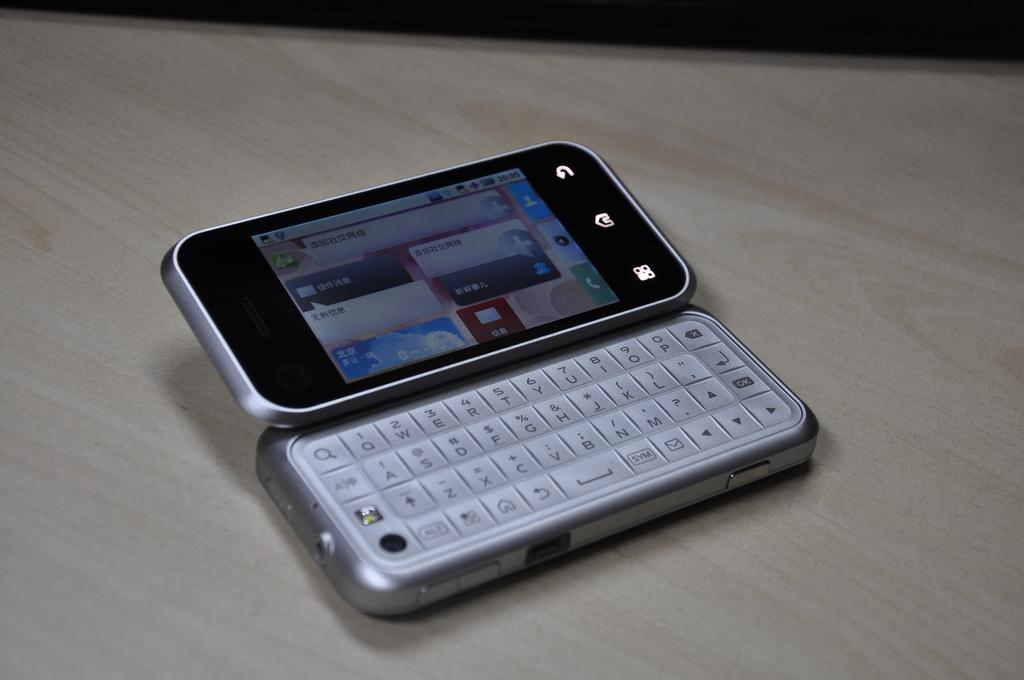<image>
Share a concise interpretation of the image provided. A cellphone with foreign writing on the screen showing a time of 20:05. 